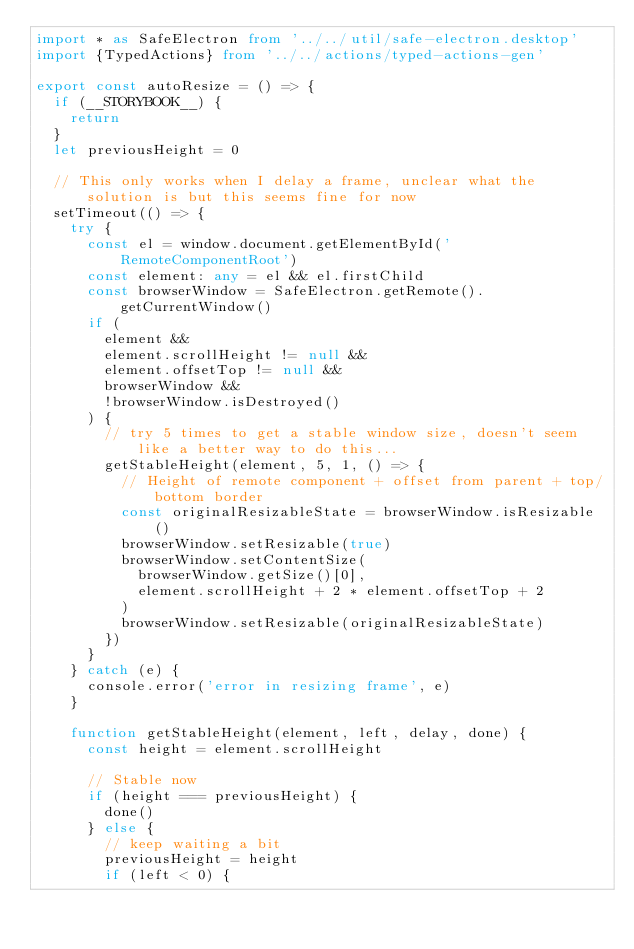Convert code to text. <code><loc_0><loc_0><loc_500><loc_500><_TypeScript_>import * as SafeElectron from '../../util/safe-electron.desktop'
import {TypedActions} from '../../actions/typed-actions-gen'

export const autoResize = () => {
  if (__STORYBOOK__) {
    return
  }
  let previousHeight = 0

  // This only works when I delay a frame, unclear what the solution is but this seems fine for now
  setTimeout(() => {
    try {
      const el = window.document.getElementById('RemoteComponentRoot')
      const element: any = el && el.firstChild
      const browserWindow = SafeElectron.getRemote().getCurrentWindow()
      if (
        element &&
        element.scrollHeight != null &&
        element.offsetTop != null &&
        browserWindow &&
        !browserWindow.isDestroyed()
      ) {
        // try 5 times to get a stable window size, doesn't seem like a better way to do this...
        getStableHeight(element, 5, 1, () => {
          // Height of remote component + offset from parent + top/bottom border
          const originalResizableState = browserWindow.isResizable()
          browserWindow.setResizable(true)
          browserWindow.setContentSize(
            browserWindow.getSize()[0],
            element.scrollHeight + 2 * element.offsetTop + 2
          )
          browserWindow.setResizable(originalResizableState)
        })
      }
    } catch (e) {
      console.error('error in resizing frame', e)
    }

    function getStableHeight(element, left, delay, done) {
      const height = element.scrollHeight

      // Stable now
      if (height === previousHeight) {
        done()
      } else {
        // keep waiting a bit
        previousHeight = height
        if (left < 0) {</code> 